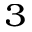<formula> <loc_0><loc_0><loc_500><loc_500>_ { 3 }</formula> 